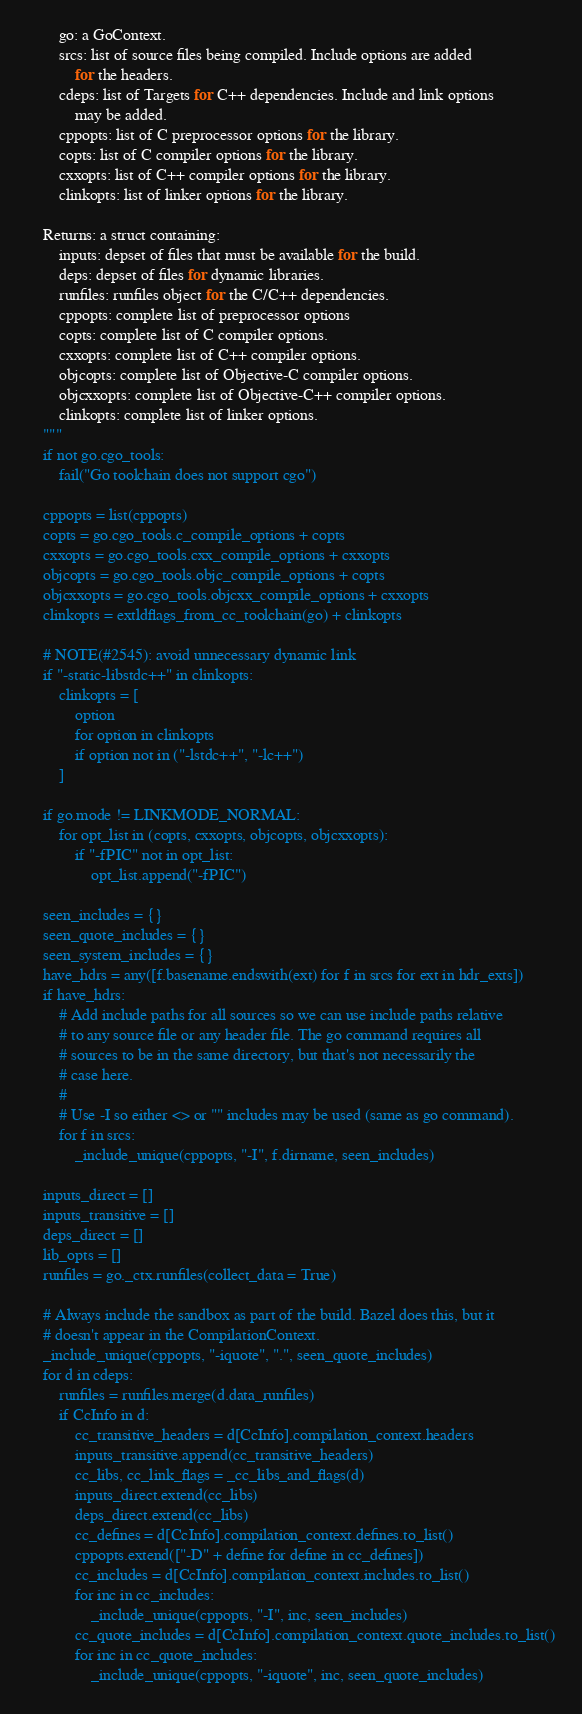<code> <loc_0><loc_0><loc_500><loc_500><_Python_>        go: a GoContext.
        srcs: list of source files being compiled. Include options are added
            for the headers.
        cdeps: list of Targets for C++ dependencies. Include and link options
            may be added.
        cppopts: list of C preprocessor options for the library.
        copts: list of C compiler options for the library.
        cxxopts: list of C++ compiler options for the library.
        clinkopts: list of linker options for the library.

    Returns: a struct containing:
        inputs: depset of files that must be available for the build.
        deps: depset of files for dynamic libraries.
        runfiles: runfiles object for the C/C++ dependencies.
        cppopts: complete list of preprocessor options
        copts: complete list of C compiler options.
        cxxopts: complete list of C++ compiler options.
        objcopts: complete list of Objective-C compiler options.
        objcxxopts: complete list of Objective-C++ compiler options.
        clinkopts: complete list of linker options.
    """
    if not go.cgo_tools:
        fail("Go toolchain does not support cgo")

    cppopts = list(cppopts)
    copts = go.cgo_tools.c_compile_options + copts
    cxxopts = go.cgo_tools.cxx_compile_options + cxxopts
    objcopts = go.cgo_tools.objc_compile_options + copts
    objcxxopts = go.cgo_tools.objcxx_compile_options + cxxopts
    clinkopts = extldflags_from_cc_toolchain(go) + clinkopts

    # NOTE(#2545): avoid unnecessary dynamic link
    if "-static-libstdc++" in clinkopts:
        clinkopts = [
            option
            for option in clinkopts
            if option not in ("-lstdc++", "-lc++")
        ]

    if go.mode != LINKMODE_NORMAL:
        for opt_list in (copts, cxxopts, objcopts, objcxxopts):
            if "-fPIC" not in opt_list:
                opt_list.append("-fPIC")

    seen_includes = {}
    seen_quote_includes = {}
    seen_system_includes = {}
    have_hdrs = any([f.basename.endswith(ext) for f in srcs for ext in hdr_exts])
    if have_hdrs:
        # Add include paths for all sources so we can use include paths relative
        # to any source file or any header file. The go command requires all
        # sources to be in the same directory, but that's not necessarily the
        # case here.
        #
        # Use -I so either <> or "" includes may be used (same as go command).
        for f in srcs:
            _include_unique(cppopts, "-I", f.dirname, seen_includes)

    inputs_direct = []
    inputs_transitive = []
    deps_direct = []
    lib_opts = []
    runfiles = go._ctx.runfiles(collect_data = True)

    # Always include the sandbox as part of the build. Bazel does this, but it
    # doesn't appear in the CompilationContext.
    _include_unique(cppopts, "-iquote", ".", seen_quote_includes)
    for d in cdeps:
        runfiles = runfiles.merge(d.data_runfiles)
        if CcInfo in d:
            cc_transitive_headers = d[CcInfo].compilation_context.headers
            inputs_transitive.append(cc_transitive_headers)
            cc_libs, cc_link_flags = _cc_libs_and_flags(d)
            inputs_direct.extend(cc_libs)
            deps_direct.extend(cc_libs)
            cc_defines = d[CcInfo].compilation_context.defines.to_list()
            cppopts.extend(["-D" + define for define in cc_defines])
            cc_includes = d[CcInfo].compilation_context.includes.to_list()
            for inc in cc_includes:
                _include_unique(cppopts, "-I", inc, seen_includes)
            cc_quote_includes = d[CcInfo].compilation_context.quote_includes.to_list()
            for inc in cc_quote_includes:
                _include_unique(cppopts, "-iquote", inc, seen_quote_includes)</code> 